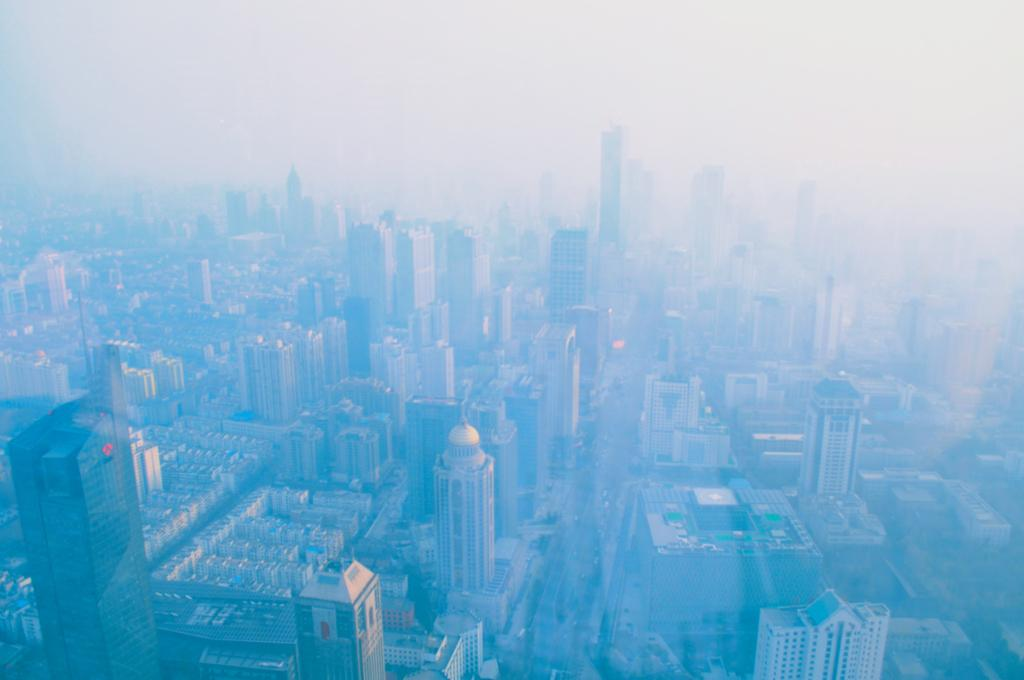What type of structures can be seen in the image? There are buildings and a tower in the image. Can you describe the tower in the image? The tower is a prominent structure in the image. What atmospheric condition is present near the tower? Fog is visible near the tower in the image. Where is the duck swimming in the image? There is no duck present in the image. What type of spacecraft can be seen near the tower in the image? There is no spacecraft present in the image; it only features buildings, a tower, and fog. 